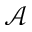<formula> <loc_0><loc_0><loc_500><loc_500>\mathcal { A }</formula> 